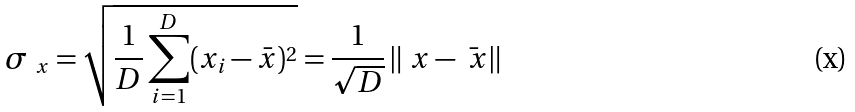<formula> <loc_0><loc_0><loc_500><loc_500>\sigma _ { \ x } = \sqrt { \frac { 1 } { D } \sum _ { i = 1 } ^ { D } ( x _ { i } - \bar { x } ) ^ { 2 } } = \frac { 1 } { \sqrt { D } } \, \| \ x - { \bar { \ x } } \|</formula> 